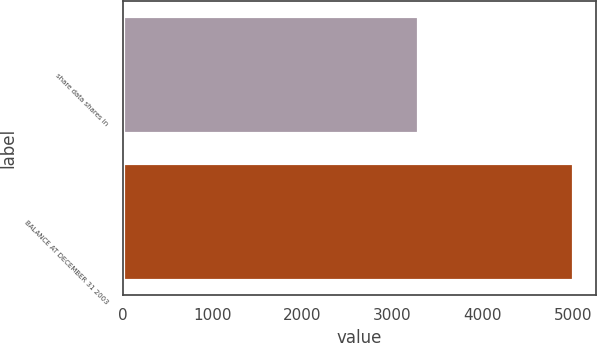Convert chart. <chart><loc_0><loc_0><loc_500><loc_500><bar_chart><fcel>share data shares in<fcel>BALANCE AT DECEMBER 31 2003<nl><fcel>3278<fcel>5007<nl></chart> 